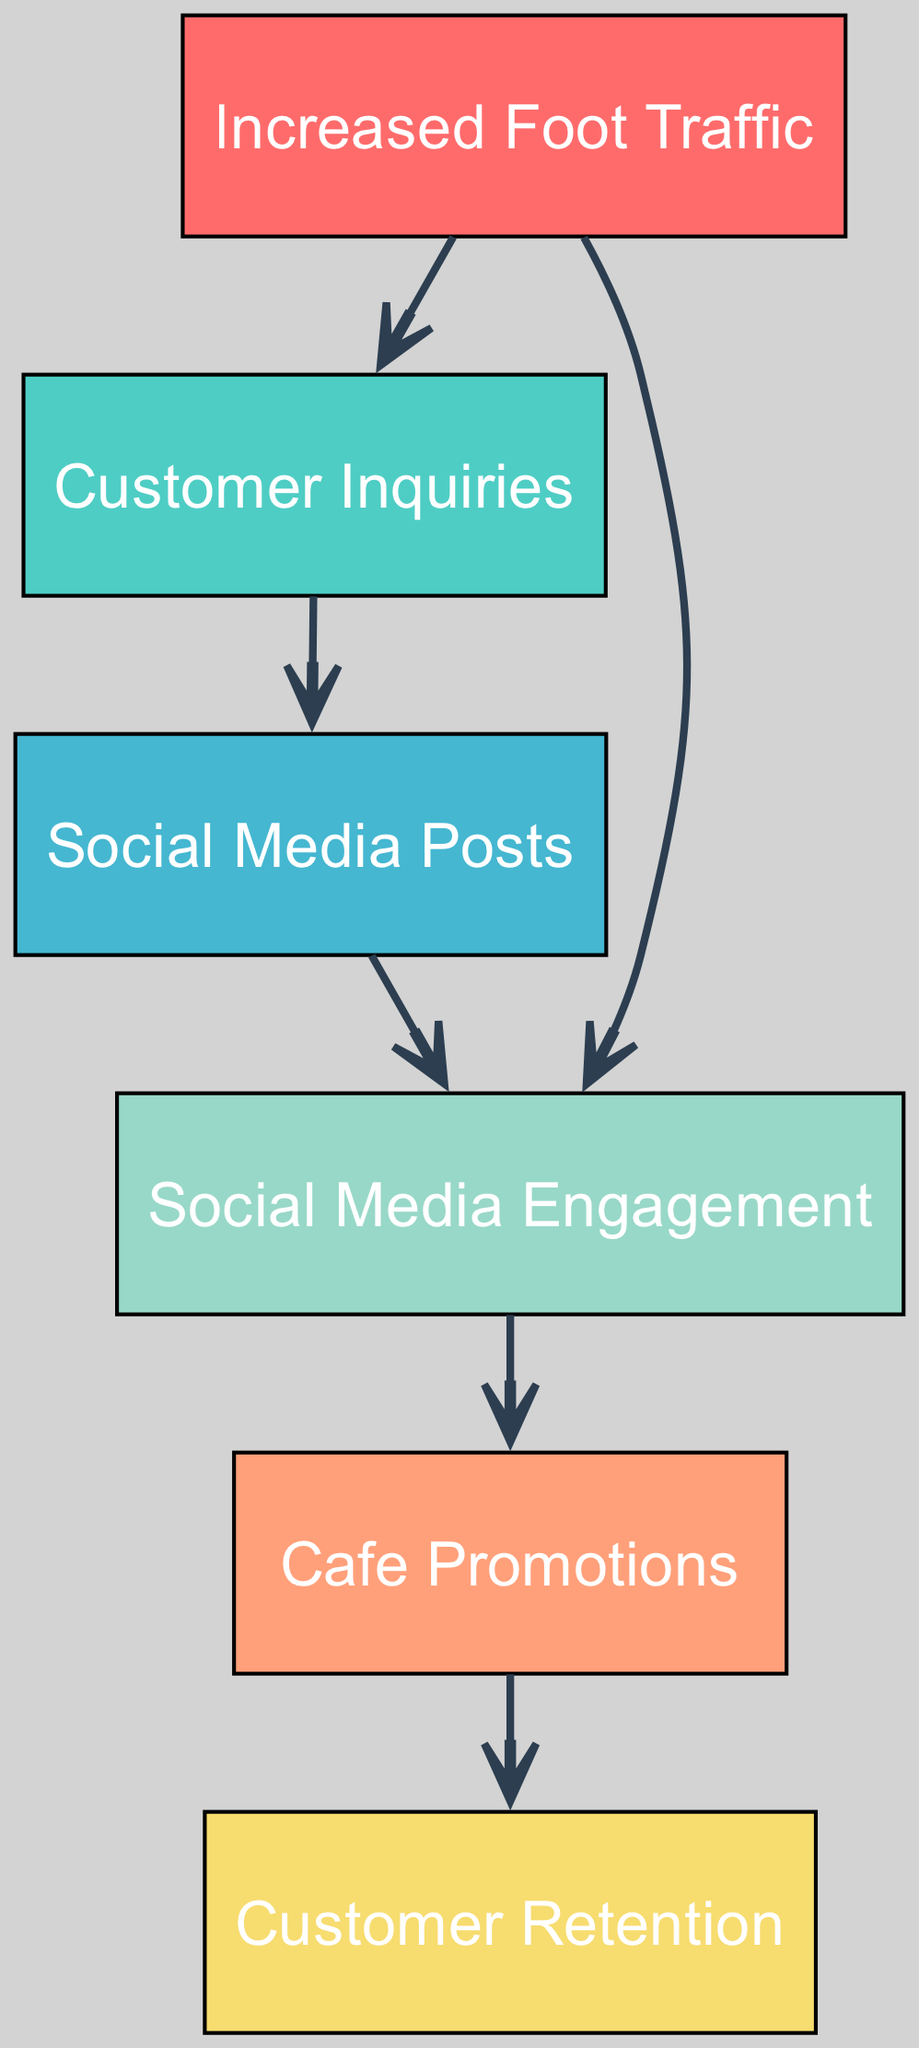What are the total number of nodes in the diagram? By counting the unique elements represented within the diagram, we can identify the following nodes: Increased Foot Traffic, Customer Inquiries, Social Media Posts, Cafe Promotions, Social Media Engagement, and Customer Retention. This totals 6 nodes.
Answer: 6 Which node comes directly after Customer Inquiries? Following the flow of the diagram, the edge indicates that Customer Inquiries lead directly to Social Media Posts, showing a direct connection between these two nodes.
Answer: Social Media Posts How many edges are represented in the diagram? To find the total number of edges, we need to count the connections listed in the edges section. There are 5 distinct edges connecting the nodes.
Answer: 5 Which node has a direct influence on Customer Retention? By tracing the edges leading to Customer Retention, we see it's influenced directly by Cafe Promotions, indicating a clear relationship where promotions affect retention.
Answer: Cafe Promotions What is the relationship between Increased Foot Traffic and Social Media Engagement? The edge from Increased Foot Traffic to Social Media Engagement shows that there is a direct influencing relationship; the increase in foot traffic leads to enhanced engagement on social media platforms.
Answer: Influencing relationship What two nodes are connected through a single path starting from Foot Traffic? Following the direct edges from Foot Traffic, we can see two paths: Foot Traffic to Customer Inquiries to Social Media Posts, or Foot Traffic directly to Social Media Engagement, creating two separate routes.
Answer: Customer Inquiries and Social Media Posts Which node is the last in the flow of edges? Tracing the directed edges from the initial node through to the end of the pathways, we find that Customer Retention is the terminal node of this flow, marking the endpoint of interactions.
Answer: Customer Retention What can directly impact Social Media Engagement from Increased Foot Traffic? Increased Foot Traffic impacts Social Media Engagement directly through an edge in the directed graph, establishing a clear connection where foot traffic can enhance engagement levels on social media.
Answer: Social Media Engagement How does Customer Inquiries influence Social Media Posts? The diagram shows a direct edge from Customer Inquiries to Social Media Posts, indicating that an increase in customer inquiries likely drives the creation and posting of content on social media platforms.
Answer: Direct influence 